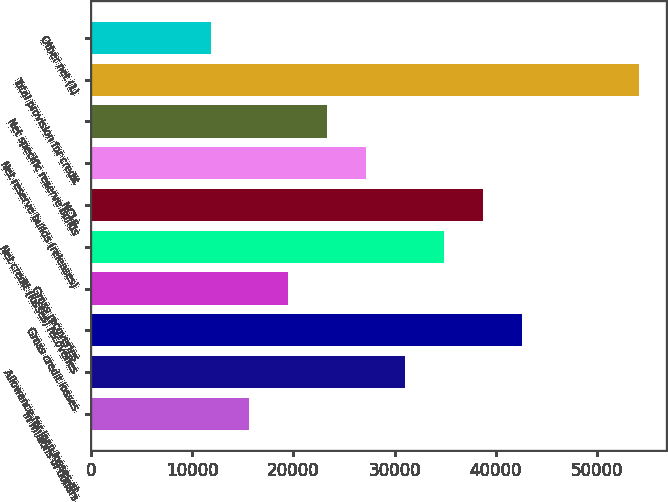Convert chart to OTSL. <chart><loc_0><loc_0><loc_500><loc_500><bar_chart><fcel>In millions of dollars<fcel>Allowance for loan losses at<fcel>Gross credit losses<fcel>Gross recoveries<fcel>Net credit (losses) recoveries<fcel>NCLs<fcel>Net reserve builds (releases)<fcel>Net specific reserve builds<fcel>Total provision for credit<fcel>Other net (1)<nl><fcel>15650.4<fcel>31056.8<fcel>42611.6<fcel>19502<fcel>34908.4<fcel>38760<fcel>27205.2<fcel>23353.6<fcel>54166.4<fcel>11798.8<nl></chart> 